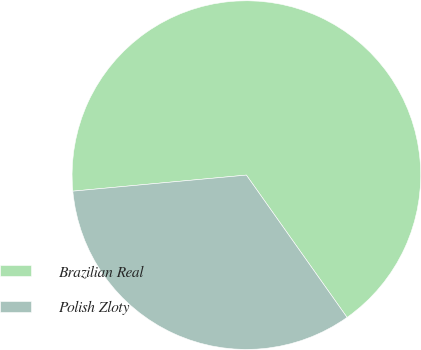Convert chart. <chart><loc_0><loc_0><loc_500><loc_500><pie_chart><fcel>Brazilian Real<fcel>Polish Zloty<nl><fcel>66.67%<fcel>33.33%<nl></chart> 